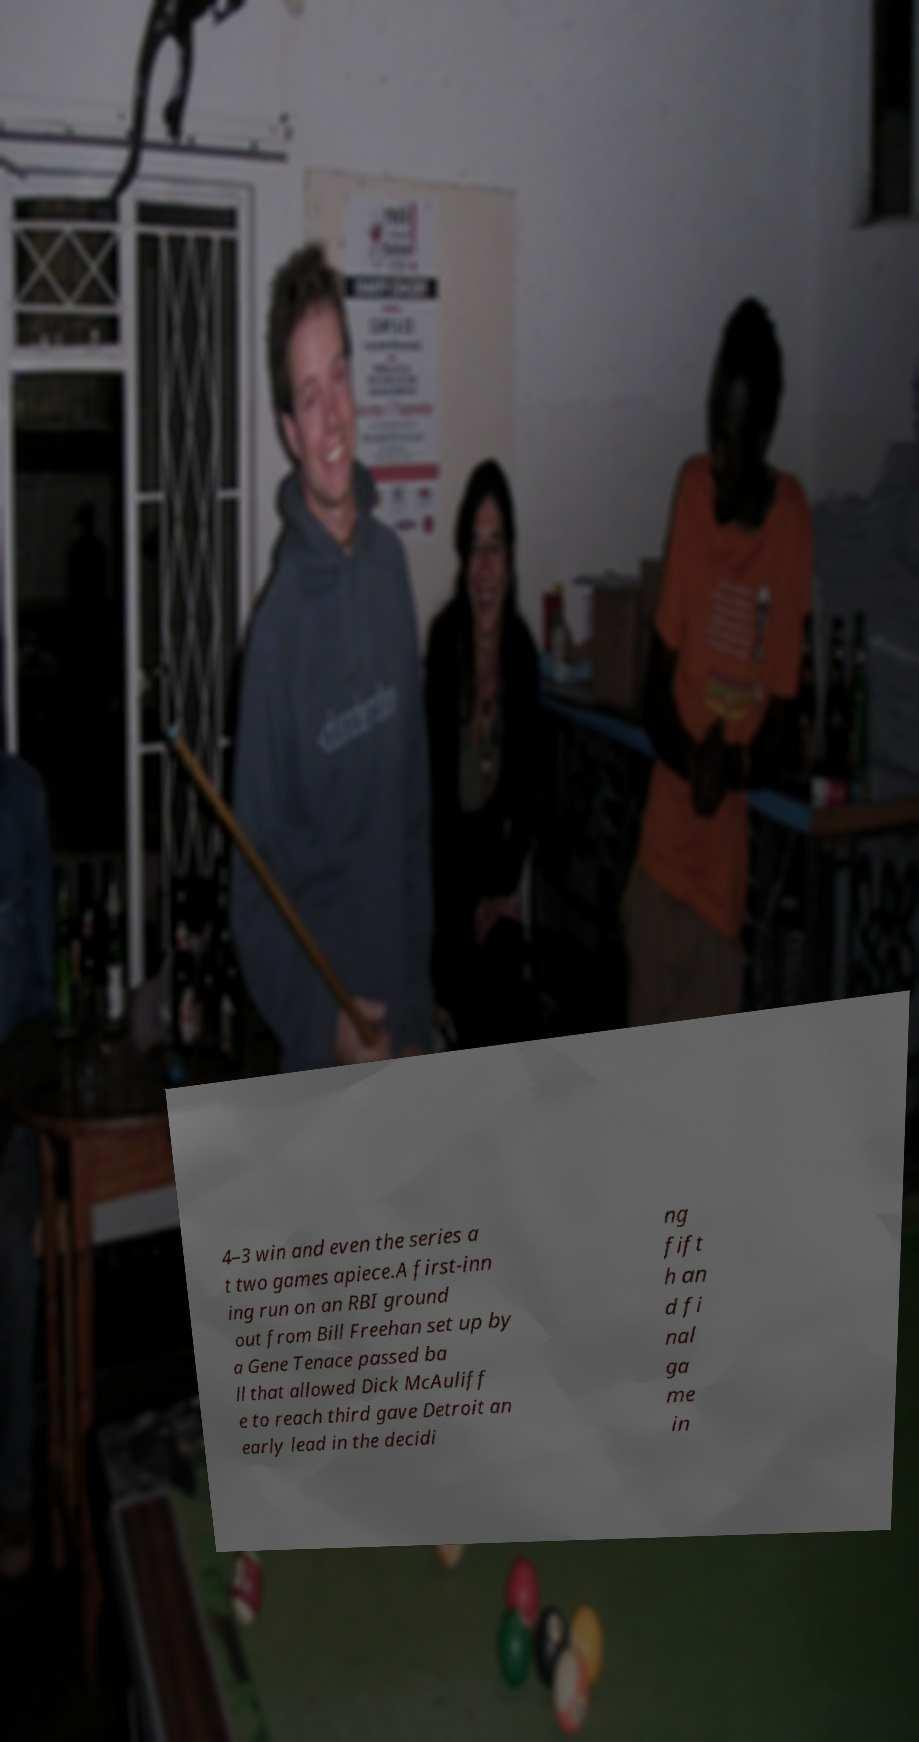Can you accurately transcribe the text from the provided image for me? 4–3 win and even the series a t two games apiece.A first-inn ing run on an RBI ground out from Bill Freehan set up by a Gene Tenace passed ba ll that allowed Dick McAuliff e to reach third gave Detroit an early lead in the decidi ng fift h an d fi nal ga me in 